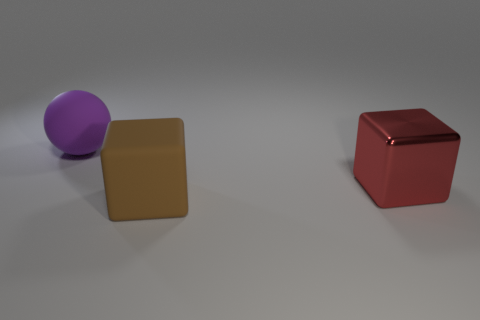There is a large rubber object left of the rubber block; what is its shape?
Make the answer very short. Sphere. Are there fewer big red blocks that are behind the large red block than matte spheres behind the large purple sphere?
Keep it short and to the point. No. Is the material of the thing that is in front of the big red shiny block the same as the big block that is to the right of the big brown rubber thing?
Your response must be concise. No. What is the shape of the big red object?
Your response must be concise. Cube. Are there more red blocks on the left side of the large red object than purple matte balls in front of the big rubber sphere?
Offer a terse response. No. Do the rubber thing that is behind the big red block and the thing in front of the big red object have the same shape?
Provide a succinct answer. No. The purple matte ball has what size?
Offer a very short reply. Large. Is the red object that is behind the big brown rubber object made of the same material as the big brown thing?
Your answer should be very brief. No. What color is the matte thing that is the same shape as the large shiny object?
Your answer should be very brief. Brown. There is a big matte object that is right of the purple matte sphere; is it the same color as the big shiny thing?
Ensure brevity in your answer.  No. 